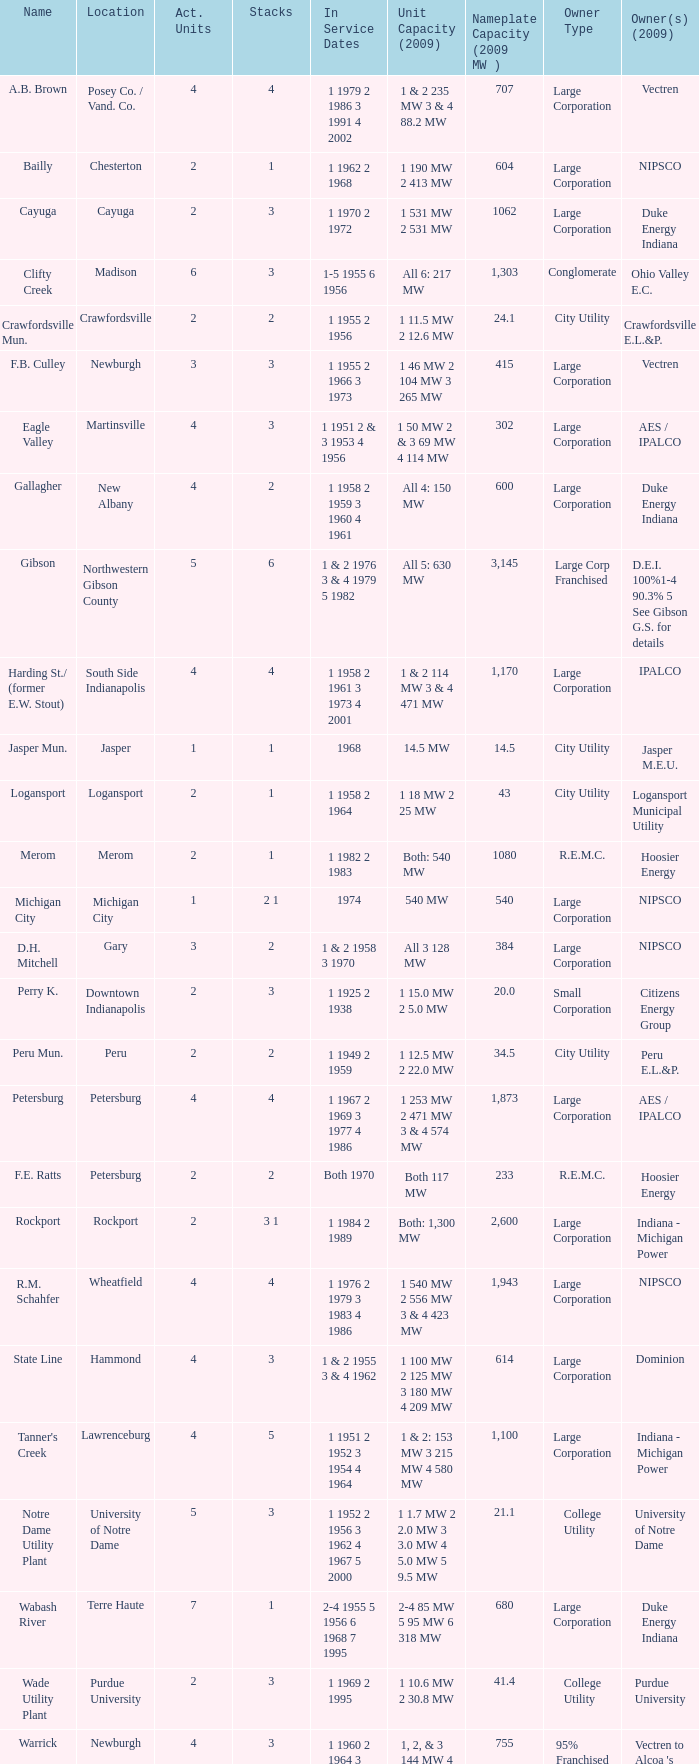Specify the heaps for 1 1969 2 1995 3.0. 